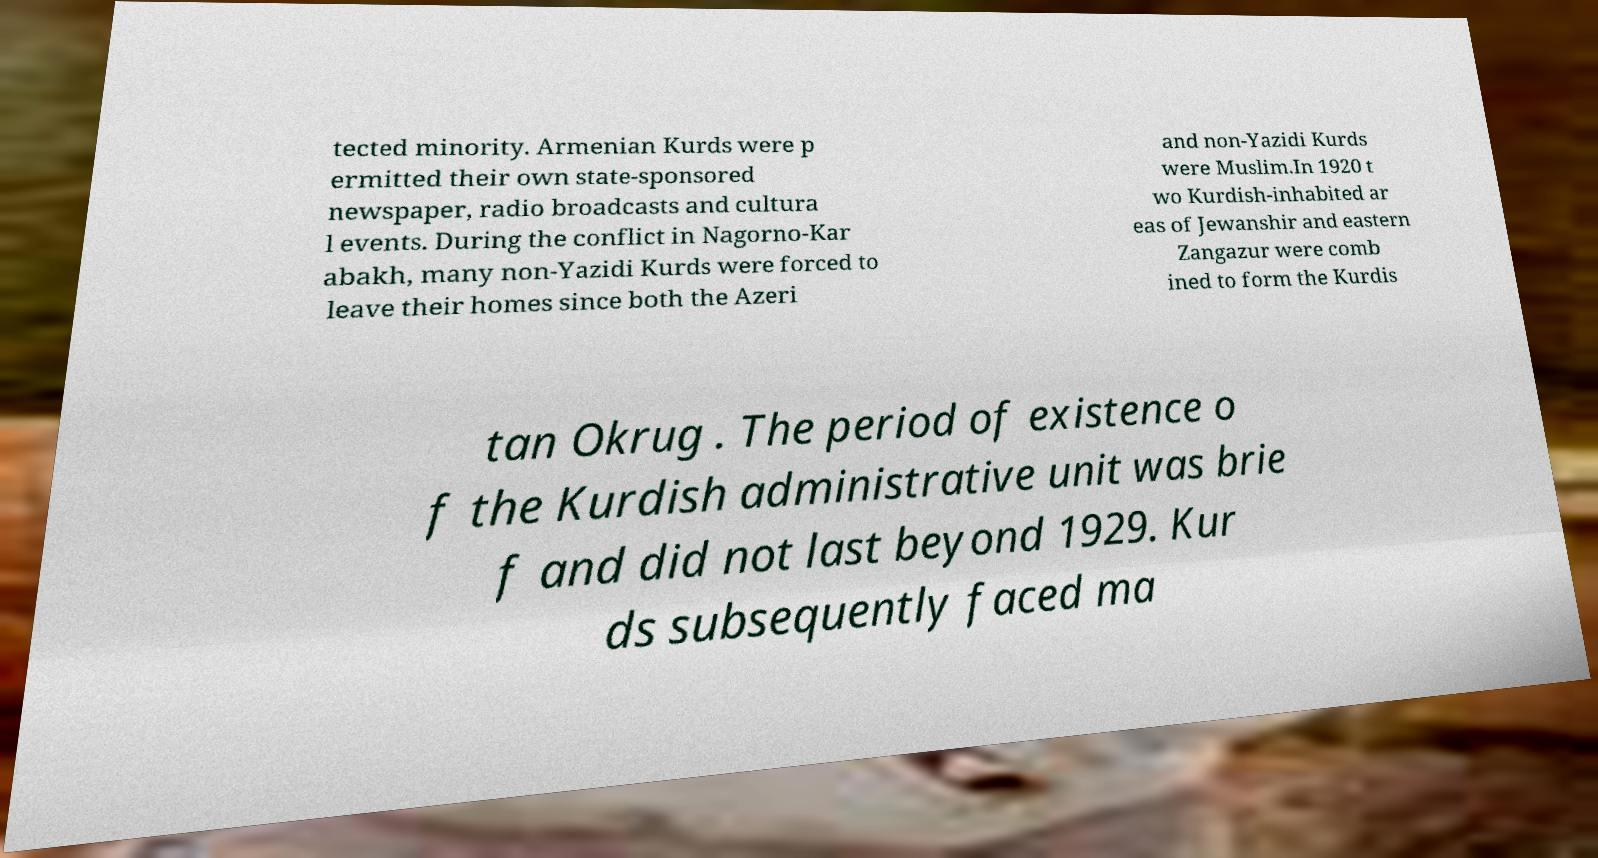Could you assist in decoding the text presented in this image and type it out clearly? tected minority. Armenian Kurds were p ermitted their own state-sponsored newspaper, radio broadcasts and cultura l events. During the conflict in Nagorno-Kar abakh, many non-Yazidi Kurds were forced to leave their homes since both the Azeri and non-Yazidi Kurds were Muslim.In 1920 t wo Kurdish-inhabited ar eas of Jewanshir and eastern Zangazur were comb ined to form the Kurdis tan Okrug . The period of existence o f the Kurdish administrative unit was brie f and did not last beyond 1929. Kur ds subsequently faced ma 